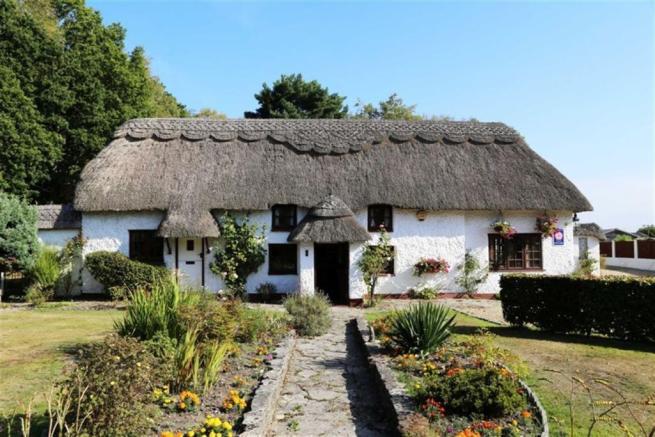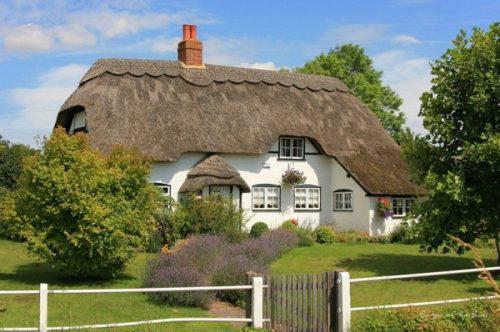The first image is the image on the left, the second image is the image on the right. Examine the images to the left and right. Is the description "All the houses have chimneys." accurate? Answer yes or no. No. The first image is the image on the left, the second image is the image on the right. Analyze the images presented: Is the assertion "At least one image shows the front of a white house with scallop trim along the top of the peaked roof, at least one notch in the roof line, and a separate roof over the front door." valid? Answer yes or no. Yes. 